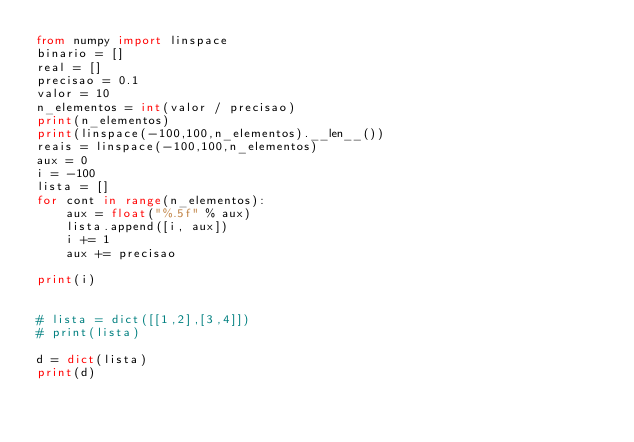Convert code to text. <code><loc_0><loc_0><loc_500><loc_500><_Python_>from numpy import linspace
binario = []
real = []
precisao = 0.1
valor = 10
n_elementos = int(valor / precisao)
print(n_elementos)
print(linspace(-100,100,n_elementos).__len__())
reais = linspace(-100,100,n_elementos)
aux = 0
i = -100
lista = []
for cont in range(n_elementos):
    aux = float("%.5f" % aux)
    lista.append([i, aux])
    i += 1
    aux += precisao

print(i)


# lista = dict([[1,2],[3,4]])
# print(lista)

d = dict(lista)
print(d)
</code> 